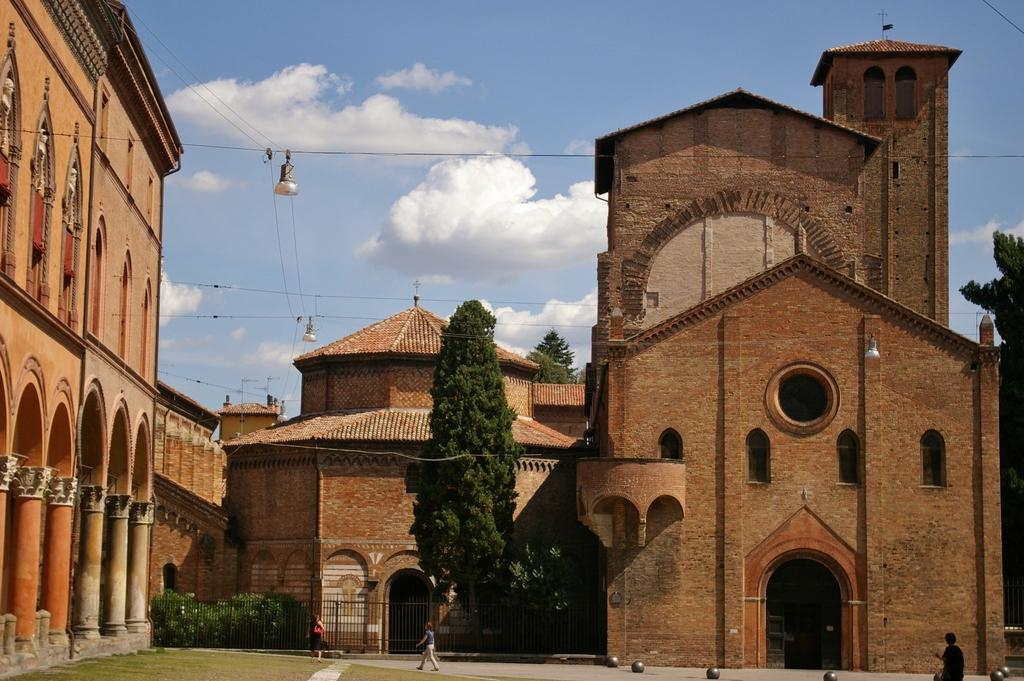What type of structures can be seen in the image? There are buildings in the image. What other natural elements are present in the image? There are trees in the image. Can you describe the people at the bottom of the image? There are people at the bottom of the image. What is visible at the top of the image? The sky is visible at the top of the image. What can be observed in the sky? Clouds are present in the sky. What type of jeans is the sleet wearing in the image? There is no sleet or jeans present in the image. What attempt is being made by the people at the bottom of the image? There is no indication of an attempt being made by the people in the image; they are simply present. 